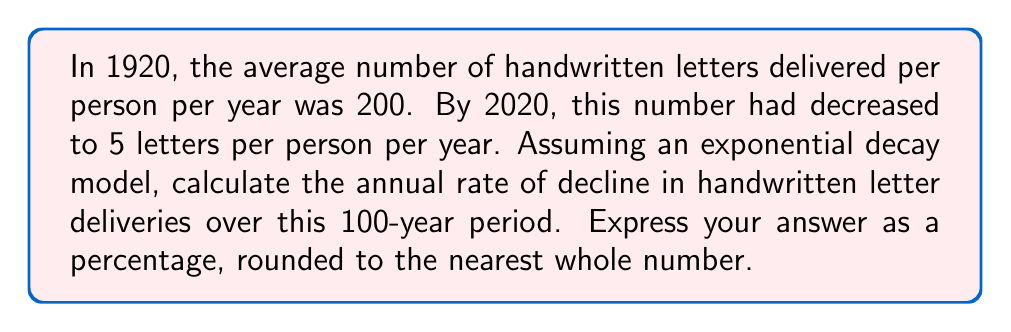Could you help me with this problem? To solve this problem, we'll use the exponential decay formula:

$$N(t) = N_0 e^{-rt}$$

Where:
$N(t)$ is the number of letters at time $t$
$N_0$ is the initial number of letters
$r$ is the rate of decay
$t$ is the time in years

We know:
$N_0 = 200$ (in 1920)
$N(100) = 5$ (in 2020, 100 years later)
$t = 100$ years

Let's plug these values into the formula:

$$5 = 200 e^{-r(100)}$$

Now, let's solve for $r$:

1) Divide both sides by 200:
   $$\frac{5}{200} = e^{-100r}$$

2) Take the natural log of both sides:
   $$\ln(\frac{5}{200}) = -100r$$

3) Solve for $r$:
   $$r = -\frac{1}{100} \ln(\frac{5}{200}) = -\frac{1}{100} \ln(0.025)$$

4) Calculate $r$:
   $$r \approx 0.0371$$

5) Convert to a percentage:
   $$0.0371 \times 100 \approx 3.71\%$$

6) Round to the nearest whole number:
   $$3.71\% \approx 4\%$$

Therefore, the annual rate of decline in handwritten letter deliveries over the 100-year period is approximately 4% per year.
Answer: 4% 